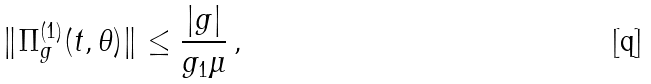Convert formula to latex. <formula><loc_0><loc_0><loc_500><loc_500>\| \Pi _ { g } ^ { ( 1 ) } ( t , \theta ) \| \leq \frac { | g | } { g _ { 1 } \mu } \, ,</formula> 